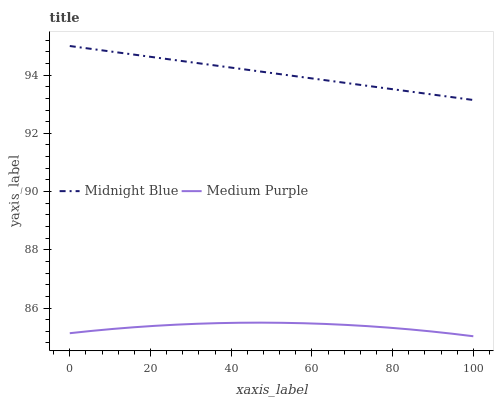Does Medium Purple have the minimum area under the curve?
Answer yes or no. Yes. Does Midnight Blue have the maximum area under the curve?
Answer yes or no. Yes. Does Midnight Blue have the minimum area under the curve?
Answer yes or no. No. Is Midnight Blue the smoothest?
Answer yes or no. Yes. Is Medium Purple the roughest?
Answer yes or no. Yes. Is Midnight Blue the roughest?
Answer yes or no. No. Does Medium Purple have the lowest value?
Answer yes or no. Yes. Does Midnight Blue have the lowest value?
Answer yes or no. No. Does Midnight Blue have the highest value?
Answer yes or no. Yes. Is Medium Purple less than Midnight Blue?
Answer yes or no. Yes. Is Midnight Blue greater than Medium Purple?
Answer yes or no. Yes. Does Medium Purple intersect Midnight Blue?
Answer yes or no. No. 